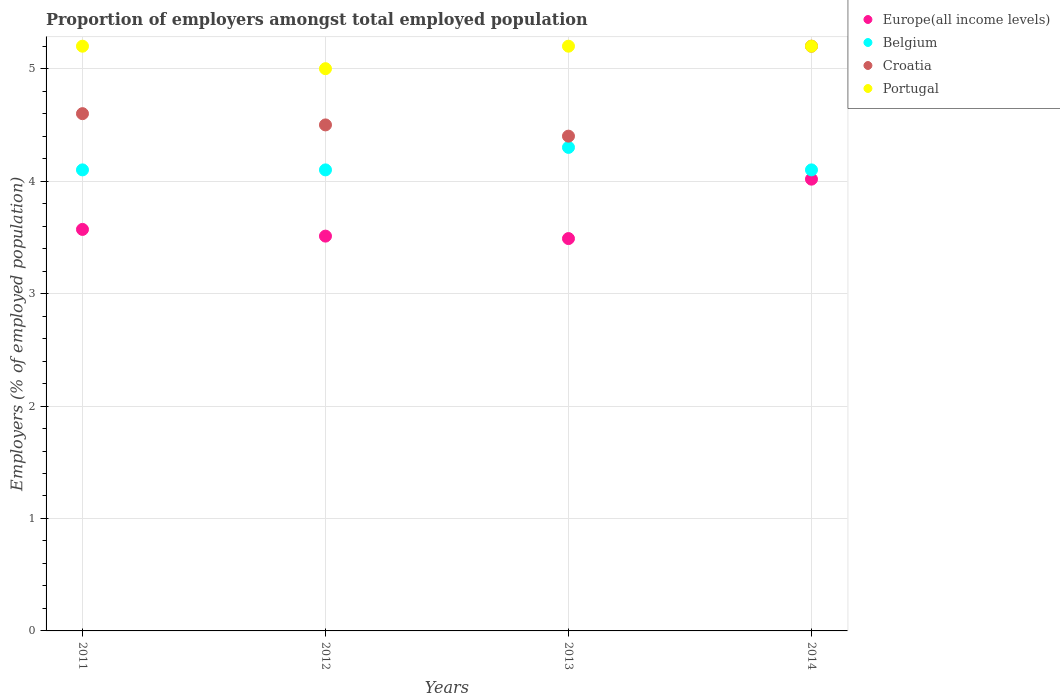Is the number of dotlines equal to the number of legend labels?
Provide a succinct answer. Yes. Across all years, what is the maximum proportion of employers in Croatia?
Ensure brevity in your answer.  5.2. In which year was the proportion of employers in Belgium maximum?
Your answer should be very brief. 2013. What is the total proportion of employers in Portugal in the graph?
Your response must be concise. 20.6. What is the difference between the proportion of employers in Belgium in 2011 and that in 2014?
Your response must be concise. 0. What is the difference between the proportion of employers in Portugal in 2011 and the proportion of employers in Belgium in 2014?
Your answer should be compact. 1.1. What is the average proportion of employers in Belgium per year?
Your answer should be very brief. 4.15. In the year 2012, what is the difference between the proportion of employers in Europe(all income levels) and proportion of employers in Belgium?
Your response must be concise. -0.59. What is the ratio of the proportion of employers in Croatia in 2011 to that in 2013?
Keep it short and to the point. 1.05. What is the difference between the highest and the second highest proportion of employers in Belgium?
Offer a terse response. 0.2. What is the difference between the highest and the lowest proportion of employers in Croatia?
Your answer should be compact. 0.8. In how many years, is the proportion of employers in Belgium greater than the average proportion of employers in Belgium taken over all years?
Your answer should be very brief. 1. Is the sum of the proportion of employers in Croatia in 2013 and 2014 greater than the maximum proportion of employers in Europe(all income levels) across all years?
Offer a terse response. Yes. Is it the case that in every year, the sum of the proportion of employers in Belgium and proportion of employers in Portugal  is greater than the sum of proportion of employers in Europe(all income levels) and proportion of employers in Croatia?
Offer a very short reply. Yes. Does the proportion of employers in Europe(all income levels) monotonically increase over the years?
Give a very brief answer. No. What is the difference between two consecutive major ticks on the Y-axis?
Give a very brief answer. 1. Are the values on the major ticks of Y-axis written in scientific E-notation?
Your answer should be compact. No. Where does the legend appear in the graph?
Offer a terse response. Top right. How many legend labels are there?
Offer a terse response. 4. How are the legend labels stacked?
Provide a short and direct response. Vertical. What is the title of the graph?
Keep it short and to the point. Proportion of employers amongst total employed population. What is the label or title of the X-axis?
Ensure brevity in your answer.  Years. What is the label or title of the Y-axis?
Your response must be concise. Employers (% of employed population). What is the Employers (% of employed population) of Europe(all income levels) in 2011?
Your response must be concise. 3.57. What is the Employers (% of employed population) in Belgium in 2011?
Provide a succinct answer. 4.1. What is the Employers (% of employed population) in Croatia in 2011?
Offer a very short reply. 4.6. What is the Employers (% of employed population) of Portugal in 2011?
Ensure brevity in your answer.  5.2. What is the Employers (% of employed population) of Europe(all income levels) in 2012?
Keep it short and to the point. 3.51. What is the Employers (% of employed population) in Belgium in 2012?
Provide a succinct answer. 4.1. What is the Employers (% of employed population) of Portugal in 2012?
Your response must be concise. 5. What is the Employers (% of employed population) in Europe(all income levels) in 2013?
Your answer should be very brief. 3.49. What is the Employers (% of employed population) in Belgium in 2013?
Provide a succinct answer. 4.3. What is the Employers (% of employed population) of Croatia in 2013?
Make the answer very short. 4.4. What is the Employers (% of employed population) in Portugal in 2013?
Offer a terse response. 5.2. What is the Employers (% of employed population) in Europe(all income levels) in 2014?
Your response must be concise. 4.02. What is the Employers (% of employed population) in Belgium in 2014?
Offer a terse response. 4.1. What is the Employers (% of employed population) in Croatia in 2014?
Offer a very short reply. 5.2. What is the Employers (% of employed population) in Portugal in 2014?
Keep it short and to the point. 5.2. Across all years, what is the maximum Employers (% of employed population) of Europe(all income levels)?
Your answer should be compact. 4.02. Across all years, what is the maximum Employers (% of employed population) of Belgium?
Provide a succinct answer. 4.3. Across all years, what is the maximum Employers (% of employed population) in Croatia?
Make the answer very short. 5.2. Across all years, what is the maximum Employers (% of employed population) in Portugal?
Provide a short and direct response. 5.2. Across all years, what is the minimum Employers (% of employed population) of Europe(all income levels)?
Provide a short and direct response. 3.49. Across all years, what is the minimum Employers (% of employed population) of Belgium?
Your answer should be very brief. 4.1. Across all years, what is the minimum Employers (% of employed population) in Croatia?
Make the answer very short. 4.4. What is the total Employers (% of employed population) in Europe(all income levels) in the graph?
Keep it short and to the point. 14.59. What is the total Employers (% of employed population) of Belgium in the graph?
Ensure brevity in your answer.  16.6. What is the total Employers (% of employed population) in Portugal in the graph?
Your answer should be very brief. 20.6. What is the difference between the Employers (% of employed population) of Europe(all income levels) in 2011 and that in 2012?
Your response must be concise. 0.06. What is the difference between the Employers (% of employed population) in Belgium in 2011 and that in 2012?
Ensure brevity in your answer.  0. What is the difference between the Employers (% of employed population) of Portugal in 2011 and that in 2012?
Offer a terse response. 0.2. What is the difference between the Employers (% of employed population) in Europe(all income levels) in 2011 and that in 2013?
Keep it short and to the point. 0.08. What is the difference between the Employers (% of employed population) of Belgium in 2011 and that in 2013?
Your response must be concise. -0.2. What is the difference between the Employers (% of employed population) of Portugal in 2011 and that in 2013?
Ensure brevity in your answer.  0. What is the difference between the Employers (% of employed population) of Europe(all income levels) in 2011 and that in 2014?
Your answer should be very brief. -0.45. What is the difference between the Employers (% of employed population) in Belgium in 2011 and that in 2014?
Your answer should be compact. 0. What is the difference between the Employers (% of employed population) in Europe(all income levels) in 2012 and that in 2013?
Provide a succinct answer. 0.02. What is the difference between the Employers (% of employed population) in Belgium in 2012 and that in 2013?
Your response must be concise. -0.2. What is the difference between the Employers (% of employed population) of Portugal in 2012 and that in 2013?
Provide a short and direct response. -0.2. What is the difference between the Employers (% of employed population) of Europe(all income levels) in 2012 and that in 2014?
Provide a succinct answer. -0.51. What is the difference between the Employers (% of employed population) in Europe(all income levels) in 2013 and that in 2014?
Keep it short and to the point. -0.53. What is the difference between the Employers (% of employed population) of Croatia in 2013 and that in 2014?
Provide a succinct answer. -0.8. What is the difference between the Employers (% of employed population) in Europe(all income levels) in 2011 and the Employers (% of employed population) in Belgium in 2012?
Make the answer very short. -0.53. What is the difference between the Employers (% of employed population) in Europe(all income levels) in 2011 and the Employers (% of employed population) in Croatia in 2012?
Make the answer very short. -0.93. What is the difference between the Employers (% of employed population) in Europe(all income levels) in 2011 and the Employers (% of employed population) in Portugal in 2012?
Your response must be concise. -1.43. What is the difference between the Employers (% of employed population) in Belgium in 2011 and the Employers (% of employed population) in Croatia in 2012?
Offer a terse response. -0.4. What is the difference between the Employers (% of employed population) of Europe(all income levels) in 2011 and the Employers (% of employed population) of Belgium in 2013?
Offer a terse response. -0.73. What is the difference between the Employers (% of employed population) of Europe(all income levels) in 2011 and the Employers (% of employed population) of Croatia in 2013?
Offer a terse response. -0.83. What is the difference between the Employers (% of employed population) of Europe(all income levels) in 2011 and the Employers (% of employed population) of Portugal in 2013?
Offer a very short reply. -1.63. What is the difference between the Employers (% of employed population) in Belgium in 2011 and the Employers (% of employed population) in Portugal in 2013?
Give a very brief answer. -1.1. What is the difference between the Employers (% of employed population) of Croatia in 2011 and the Employers (% of employed population) of Portugal in 2013?
Your answer should be compact. -0.6. What is the difference between the Employers (% of employed population) in Europe(all income levels) in 2011 and the Employers (% of employed population) in Belgium in 2014?
Your answer should be compact. -0.53. What is the difference between the Employers (% of employed population) in Europe(all income levels) in 2011 and the Employers (% of employed population) in Croatia in 2014?
Your response must be concise. -1.63. What is the difference between the Employers (% of employed population) in Europe(all income levels) in 2011 and the Employers (% of employed population) in Portugal in 2014?
Give a very brief answer. -1.63. What is the difference between the Employers (% of employed population) of Belgium in 2011 and the Employers (% of employed population) of Croatia in 2014?
Provide a short and direct response. -1.1. What is the difference between the Employers (% of employed population) in Belgium in 2011 and the Employers (% of employed population) in Portugal in 2014?
Make the answer very short. -1.1. What is the difference between the Employers (% of employed population) in Croatia in 2011 and the Employers (% of employed population) in Portugal in 2014?
Provide a succinct answer. -0.6. What is the difference between the Employers (% of employed population) of Europe(all income levels) in 2012 and the Employers (% of employed population) of Belgium in 2013?
Offer a very short reply. -0.79. What is the difference between the Employers (% of employed population) of Europe(all income levels) in 2012 and the Employers (% of employed population) of Croatia in 2013?
Your answer should be very brief. -0.89. What is the difference between the Employers (% of employed population) in Europe(all income levels) in 2012 and the Employers (% of employed population) in Portugal in 2013?
Give a very brief answer. -1.69. What is the difference between the Employers (% of employed population) of Belgium in 2012 and the Employers (% of employed population) of Croatia in 2013?
Give a very brief answer. -0.3. What is the difference between the Employers (% of employed population) in Belgium in 2012 and the Employers (% of employed population) in Portugal in 2013?
Give a very brief answer. -1.1. What is the difference between the Employers (% of employed population) in Europe(all income levels) in 2012 and the Employers (% of employed population) in Belgium in 2014?
Ensure brevity in your answer.  -0.59. What is the difference between the Employers (% of employed population) in Europe(all income levels) in 2012 and the Employers (% of employed population) in Croatia in 2014?
Give a very brief answer. -1.69. What is the difference between the Employers (% of employed population) of Europe(all income levels) in 2012 and the Employers (% of employed population) of Portugal in 2014?
Offer a very short reply. -1.69. What is the difference between the Employers (% of employed population) of Europe(all income levels) in 2013 and the Employers (% of employed population) of Belgium in 2014?
Offer a terse response. -0.61. What is the difference between the Employers (% of employed population) in Europe(all income levels) in 2013 and the Employers (% of employed population) in Croatia in 2014?
Provide a succinct answer. -1.71. What is the difference between the Employers (% of employed population) in Europe(all income levels) in 2013 and the Employers (% of employed population) in Portugal in 2014?
Ensure brevity in your answer.  -1.71. What is the difference between the Employers (% of employed population) of Belgium in 2013 and the Employers (% of employed population) of Croatia in 2014?
Ensure brevity in your answer.  -0.9. What is the difference between the Employers (% of employed population) in Belgium in 2013 and the Employers (% of employed population) in Portugal in 2014?
Give a very brief answer. -0.9. What is the average Employers (% of employed population) of Europe(all income levels) per year?
Ensure brevity in your answer.  3.65. What is the average Employers (% of employed population) of Belgium per year?
Keep it short and to the point. 4.15. What is the average Employers (% of employed population) of Croatia per year?
Your answer should be very brief. 4.67. What is the average Employers (% of employed population) in Portugal per year?
Provide a short and direct response. 5.15. In the year 2011, what is the difference between the Employers (% of employed population) of Europe(all income levels) and Employers (% of employed population) of Belgium?
Keep it short and to the point. -0.53. In the year 2011, what is the difference between the Employers (% of employed population) in Europe(all income levels) and Employers (% of employed population) in Croatia?
Your answer should be compact. -1.03. In the year 2011, what is the difference between the Employers (% of employed population) in Europe(all income levels) and Employers (% of employed population) in Portugal?
Offer a terse response. -1.63. In the year 2011, what is the difference between the Employers (% of employed population) in Belgium and Employers (% of employed population) in Croatia?
Ensure brevity in your answer.  -0.5. In the year 2011, what is the difference between the Employers (% of employed population) in Croatia and Employers (% of employed population) in Portugal?
Give a very brief answer. -0.6. In the year 2012, what is the difference between the Employers (% of employed population) in Europe(all income levels) and Employers (% of employed population) in Belgium?
Keep it short and to the point. -0.59. In the year 2012, what is the difference between the Employers (% of employed population) in Europe(all income levels) and Employers (% of employed population) in Croatia?
Keep it short and to the point. -0.99. In the year 2012, what is the difference between the Employers (% of employed population) of Europe(all income levels) and Employers (% of employed population) of Portugal?
Your response must be concise. -1.49. In the year 2013, what is the difference between the Employers (% of employed population) of Europe(all income levels) and Employers (% of employed population) of Belgium?
Your answer should be very brief. -0.81. In the year 2013, what is the difference between the Employers (% of employed population) in Europe(all income levels) and Employers (% of employed population) in Croatia?
Keep it short and to the point. -0.91. In the year 2013, what is the difference between the Employers (% of employed population) of Europe(all income levels) and Employers (% of employed population) of Portugal?
Make the answer very short. -1.71. In the year 2014, what is the difference between the Employers (% of employed population) of Europe(all income levels) and Employers (% of employed population) of Belgium?
Your response must be concise. -0.08. In the year 2014, what is the difference between the Employers (% of employed population) of Europe(all income levels) and Employers (% of employed population) of Croatia?
Give a very brief answer. -1.18. In the year 2014, what is the difference between the Employers (% of employed population) of Europe(all income levels) and Employers (% of employed population) of Portugal?
Keep it short and to the point. -1.18. In the year 2014, what is the difference between the Employers (% of employed population) of Belgium and Employers (% of employed population) of Croatia?
Offer a very short reply. -1.1. What is the ratio of the Employers (% of employed population) in Europe(all income levels) in 2011 to that in 2012?
Make the answer very short. 1.02. What is the ratio of the Employers (% of employed population) in Croatia in 2011 to that in 2012?
Keep it short and to the point. 1.02. What is the ratio of the Employers (% of employed population) in Europe(all income levels) in 2011 to that in 2013?
Your response must be concise. 1.02. What is the ratio of the Employers (% of employed population) in Belgium in 2011 to that in 2013?
Make the answer very short. 0.95. What is the ratio of the Employers (% of employed population) in Croatia in 2011 to that in 2013?
Keep it short and to the point. 1.05. What is the ratio of the Employers (% of employed population) of Portugal in 2011 to that in 2013?
Offer a terse response. 1. What is the ratio of the Employers (% of employed population) of Europe(all income levels) in 2011 to that in 2014?
Give a very brief answer. 0.89. What is the ratio of the Employers (% of employed population) in Croatia in 2011 to that in 2014?
Make the answer very short. 0.88. What is the ratio of the Employers (% of employed population) in Portugal in 2011 to that in 2014?
Ensure brevity in your answer.  1. What is the ratio of the Employers (% of employed population) in Europe(all income levels) in 2012 to that in 2013?
Provide a short and direct response. 1.01. What is the ratio of the Employers (% of employed population) in Belgium in 2012 to that in 2013?
Make the answer very short. 0.95. What is the ratio of the Employers (% of employed population) of Croatia in 2012 to that in 2013?
Make the answer very short. 1.02. What is the ratio of the Employers (% of employed population) of Portugal in 2012 to that in 2013?
Offer a very short reply. 0.96. What is the ratio of the Employers (% of employed population) in Europe(all income levels) in 2012 to that in 2014?
Ensure brevity in your answer.  0.87. What is the ratio of the Employers (% of employed population) of Belgium in 2012 to that in 2014?
Offer a terse response. 1. What is the ratio of the Employers (% of employed population) of Croatia in 2012 to that in 2014?
Provide a succinct answer. 0.87. What is the ratio of the Employers (% of employed population) of Portugal in 2012 to that in 2014?
Provide a succinct answer. 0.96. What is the ratio of the Employers (% of employed population) in Europe(all income levels) in 2013 to that in 2014?
Your response must be concise. 0.87. What is the ratio of the Employers (% of employed population) in Belgium in 2013 to that in 2014?
Provide a succinct answer. 1.05. What is the ratio of the Employers (% of employed population) of Croatia in 2013 to that in 2014?
Your answer should be very brief. 0.85. What is the difference between the highest and the second highest Employers (% of employed population) in Europe(all income levels)?
Ensure brevity in your answer.  0.45. What is the difference between the highest and the second highest Employers (% of employed population) in Belgium?
Keep it short and to the point. 0.2. What is the difference between the highest and the second highest Employers (% of employed population) of Croatia?
Your response must be concise. 0.6. What is the difference between the highest and the lowest Employers (% of employed population) of Europe(all income levels)?
Ensure brevity in your answer.  0.53. What is the difference between the highest and the lowest Employers (% of employed population) of Belgium?
Ensure brevity in your answer.  0.2. 